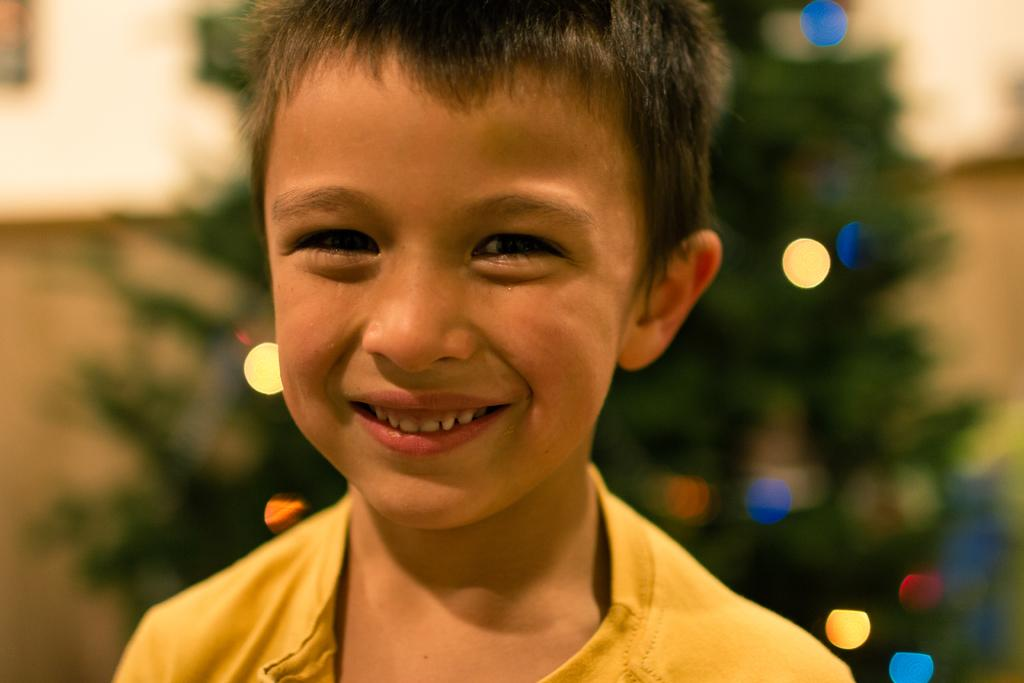What is the main subject of the image? There is a child in the image. What is the child wearing? The child is wearing a yellow dress. What is the child's expression in the image? The child is smiling. Can you describe the background of the image? The background of the image is blurred. What can be seen in the background of the image? There is a tree and lights visible in the background. What type of toy is the child playing with in the image? There is no toy visible in the image; the child is simply smiling and wearing a yellow dress. 